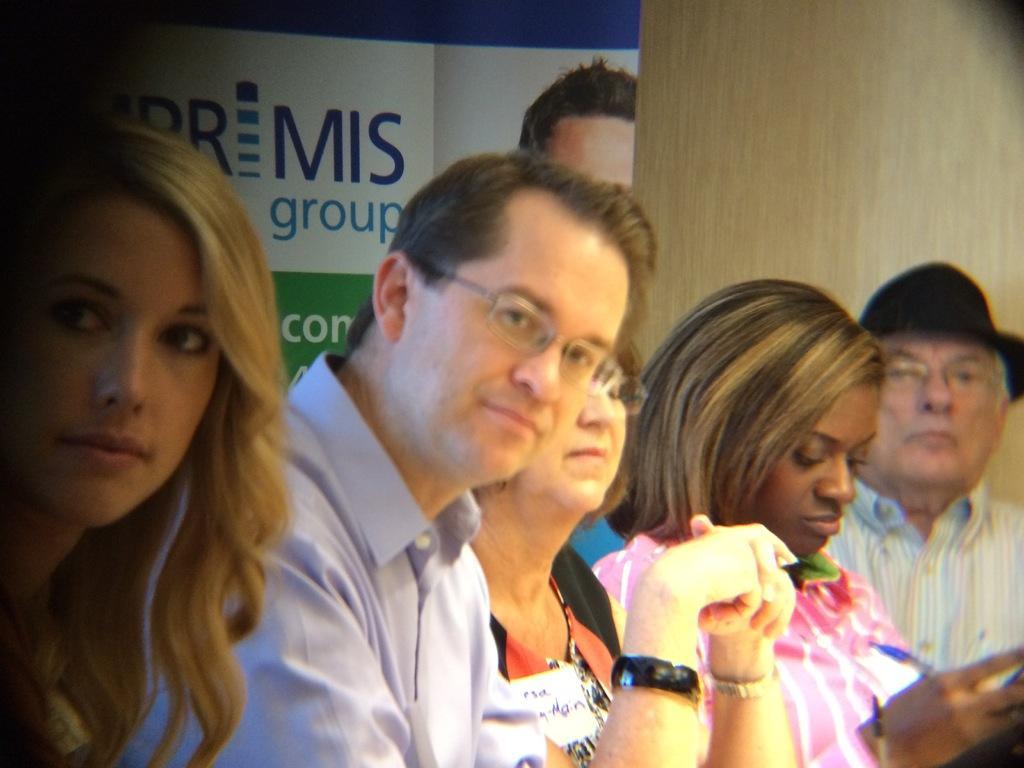Describe this image in one or two sentences. In this picture there are group of people sitting and there is a woman with pink shirt is sitting and holding the object. At the back there is a board and there is text and there is a picture of a person on the board. 